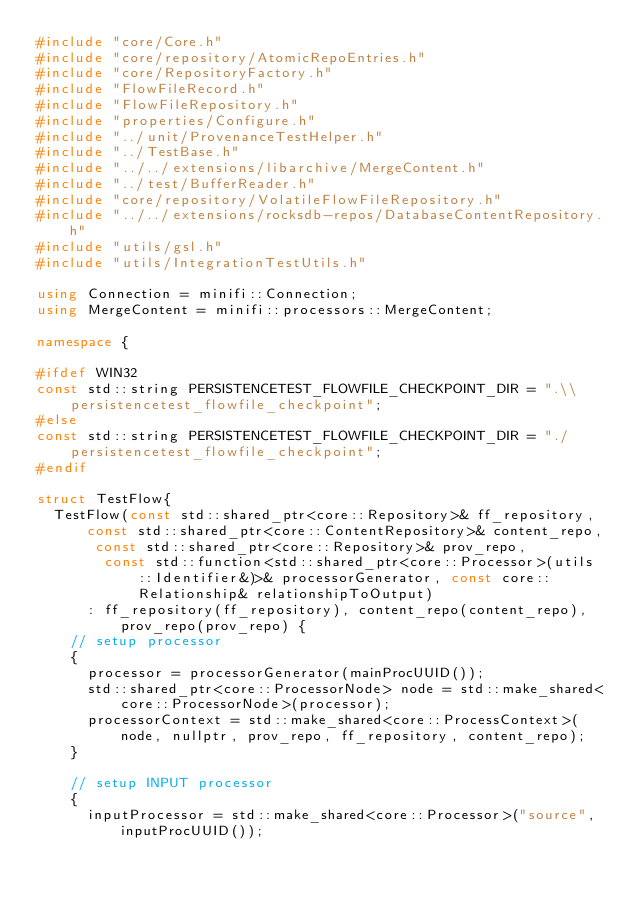<code> <loc_0><loc_0><loc_500><loc_500><_C++_>#include "core/Core.h"
#include "core/repository/AtomicRepoEntries.h"
#include "core/RepositoryFactory.h"
#include "FlowFileRecord.h"
#include "FlowFileRepository.h"
#include "properties/Configure.h"
#include "../unit/ProvenanceTestHelper.h"
#include "../TestBase.h"
#include "../../extensions/libarchive/MergeContent.h"
#include "../test/BufferReader.h"
#include "core/repository/VolatileFlowFileRepository.h"
#include "../../extensions/rocksdb-repos/DatabaseContentRepository.h"
#include "utils/gsl.h"
#include "utils/IntegrationTestUtils.h"

using Connection = minifi::Connection;
using MergeContent = minifi::processors::MergeContent;

namespace {

#ifdef WIN32
const std::string PERSISTENCETEST_FLOWFILE_CHECKPOINT_DIR = ".\\persistencetest_flowfile_checkpoint";
#else
const std::string PERSISTENCETEST_FLOWFILE_CHECKPOINT_DIR = "./persistencetest_flowfile_checkpoint";
#endif

struct TestFlow{
  TestFlow(const std::shared_ptr<core::Repository>& ff_repository, const std::shared_ptr<core::ContentRepository>& content_repo, const std::shared_ptr<core::Repository>& prov_repo,
        const std::function<std::shared_ptr<core::Processor>(utils::Identifier&)>& processorGenerator, const core::Relationship& relationshipToOutput)
      : ff_repository(ff_repository), content_repo(content_repo), prov_repo(prov_repo) {
    // setup processor
    {
      processor = processorGenerator(mainProcUUID());
      std::shared_ptr<core::ProcessorNode> node = std::make_shared<core::ProcessorNode>(processor);
      processorContext = std::make_shared<core::ProcessContext>(node, nullptr, prov_repo, ff_repository, content_repo);
    }

    // setup INPUT processor
    {
      inputProcessor = std::make_shared<core::Processor>("source", inputProcUUID());</code> 